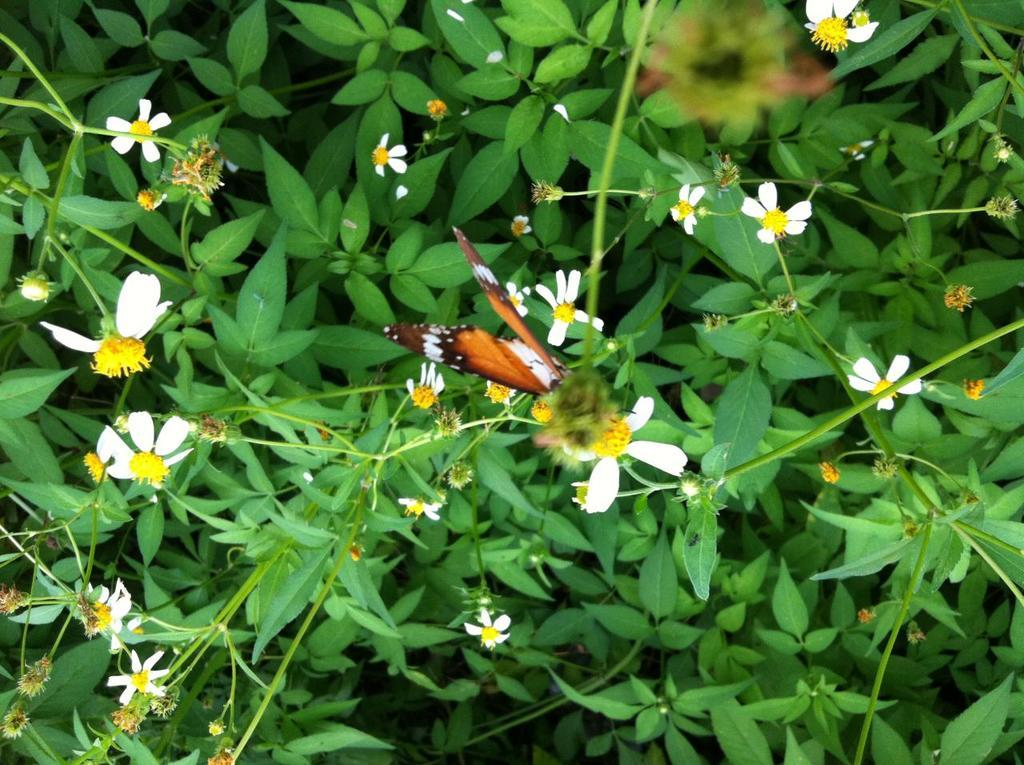What type of living organisms are present in the image? There are plants in the image. What specific features can be observed on the plants? The plants have flowers and buds. What color are the flowers on the plants? The flowers are white in color. Are there any other creatures present in the image besides the plants? Yes, there is a butterfly on one of the flowers. Where is the toothbrush located in the image? There is no toothbrush present in the image. What is the cast doing in the middle of the image? There is no cast present in the image. 